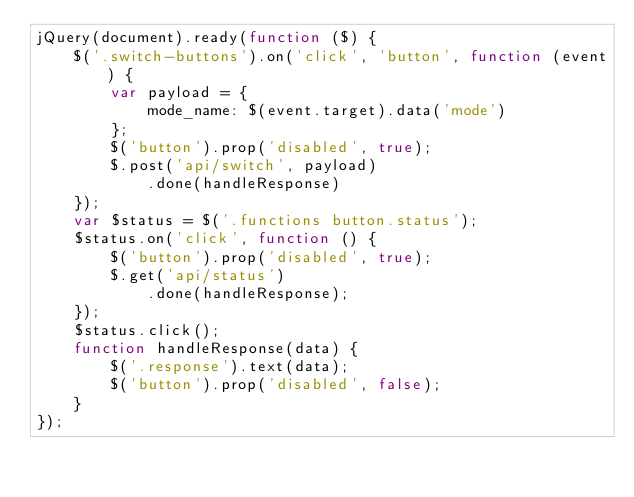<code> <loc_0><loc_0><loc_500><loc_500><_JavaScript_>jQuery(document).ready(function ($) {
    $('.switch-buttons').on('click', 'button', function (event) {
        var payload = {
            mode_name: $(event.target).data('mode')
        };
        $('button').prop('disabled', true);
        $.post('api/switch', payload)
            .done(handleResponse)
    });
    var $status = $('.functions button.status');
    $status.on('click', function () {
        $('button').prop('disabled', true);
        $.get('api/status')
            .done(handleResponse);
    });
    $status.click();
    function handleResponse(data) {
        $('.response').text(data);
        $('button').prop('disabled', false);
    }
});
</code> 